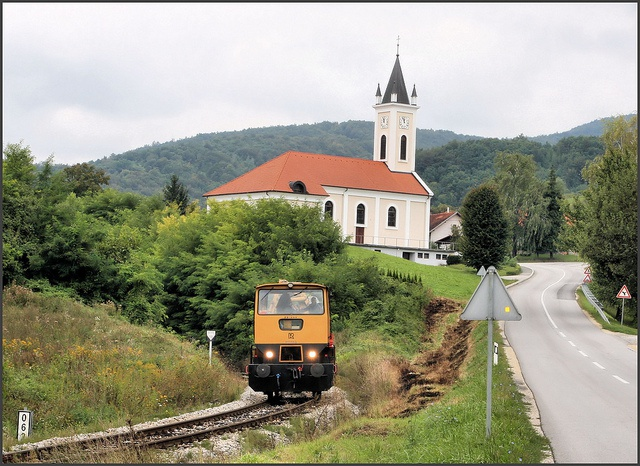Describe the objects in this image and their specific colors. I can see train in black, orange, darkgray, and gray tones, people in black, darkgray, gray, and lightgray tones, and people in black, gray, and darkgray tones in this image. 